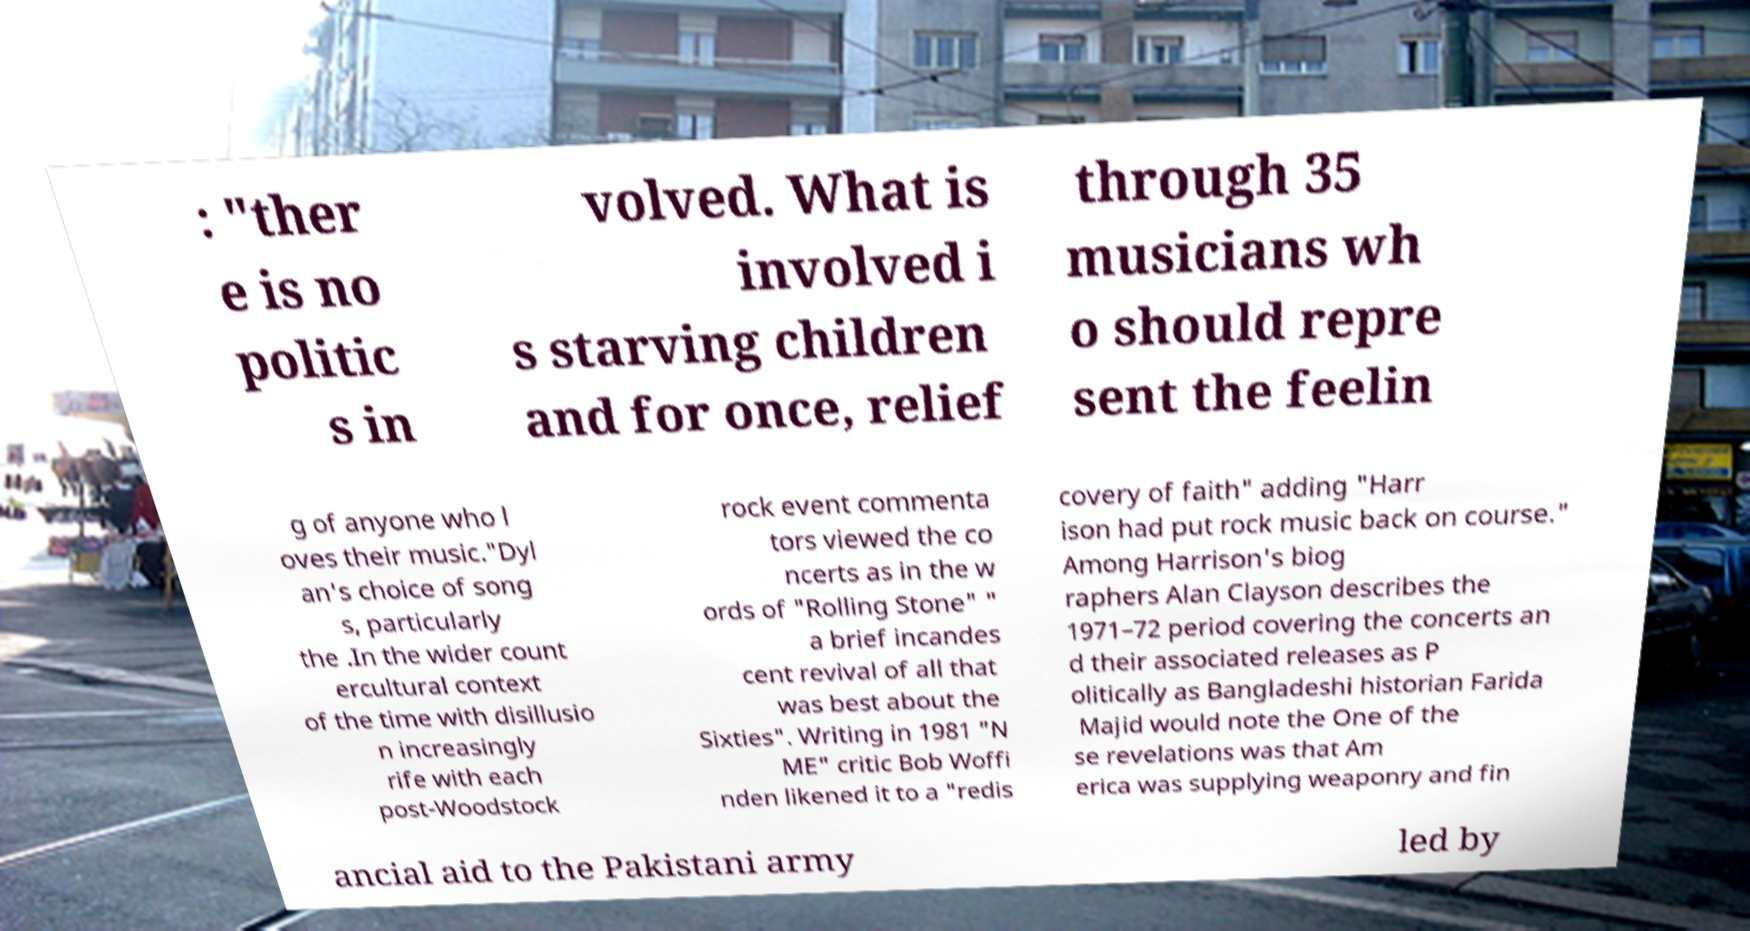What messages or text are displayed in this image? I need them in a readable, typed format. : "ther e is no politic s in volved. What is involved i s starving children and for once, relief through 35 musicians wh o should repre sent the feelin g of anyone who l oves their music."Dyl an's choice of song s, particularly the .In the wider count ercultural context of the time with disillusio n increasingly rife with each post-Woodstock rock event commenta tors viewed the co ncerts as in the w ords of "Rolling Stone" " a brief incandes cent revival of all that was best about the Sixties". Writing in 1981 "N ME" critic Bob Woffi nden likened it to a "redis covery of faith" adding "Harr ison had put rock music back on course." Among Harrison's biog raphers Alan Clayson describes the 1971–72 period covering the concerts an d their associated releases as P olitically as Bangladeshi historian Farida Majid would note the One of the se revelations was that Am erica was supplying weaponry and fin ancial aid to the Pakistani army led by 